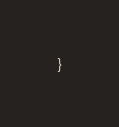<code> <loc_0><loc_0><loc_500><loc_500><_Java_>}
</code> 